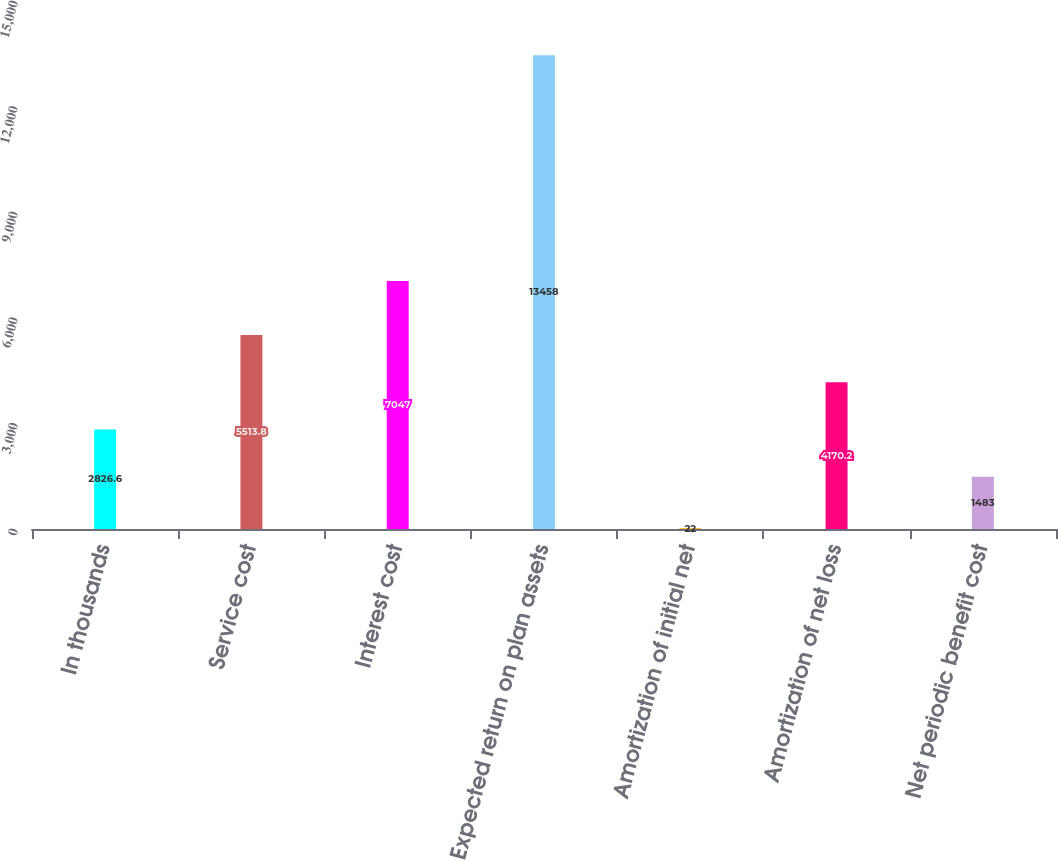<chart> <loc_0><loc_0><loc_500><loc_500><bar_chart><fcel>In thousands<fcel>Service cost<fcel>Interest cost<fcel>Expected return on plan assets<fcel>Amortization of initial net<fcel>Amortization of net loss<fcel>Net periodic benefit cost<nl><fcel>2826.6<fcel>5513.8<fcel>7047<fcel>13458<fcel>22<fcel>4170.2<fcel>1483<nl></chart> 